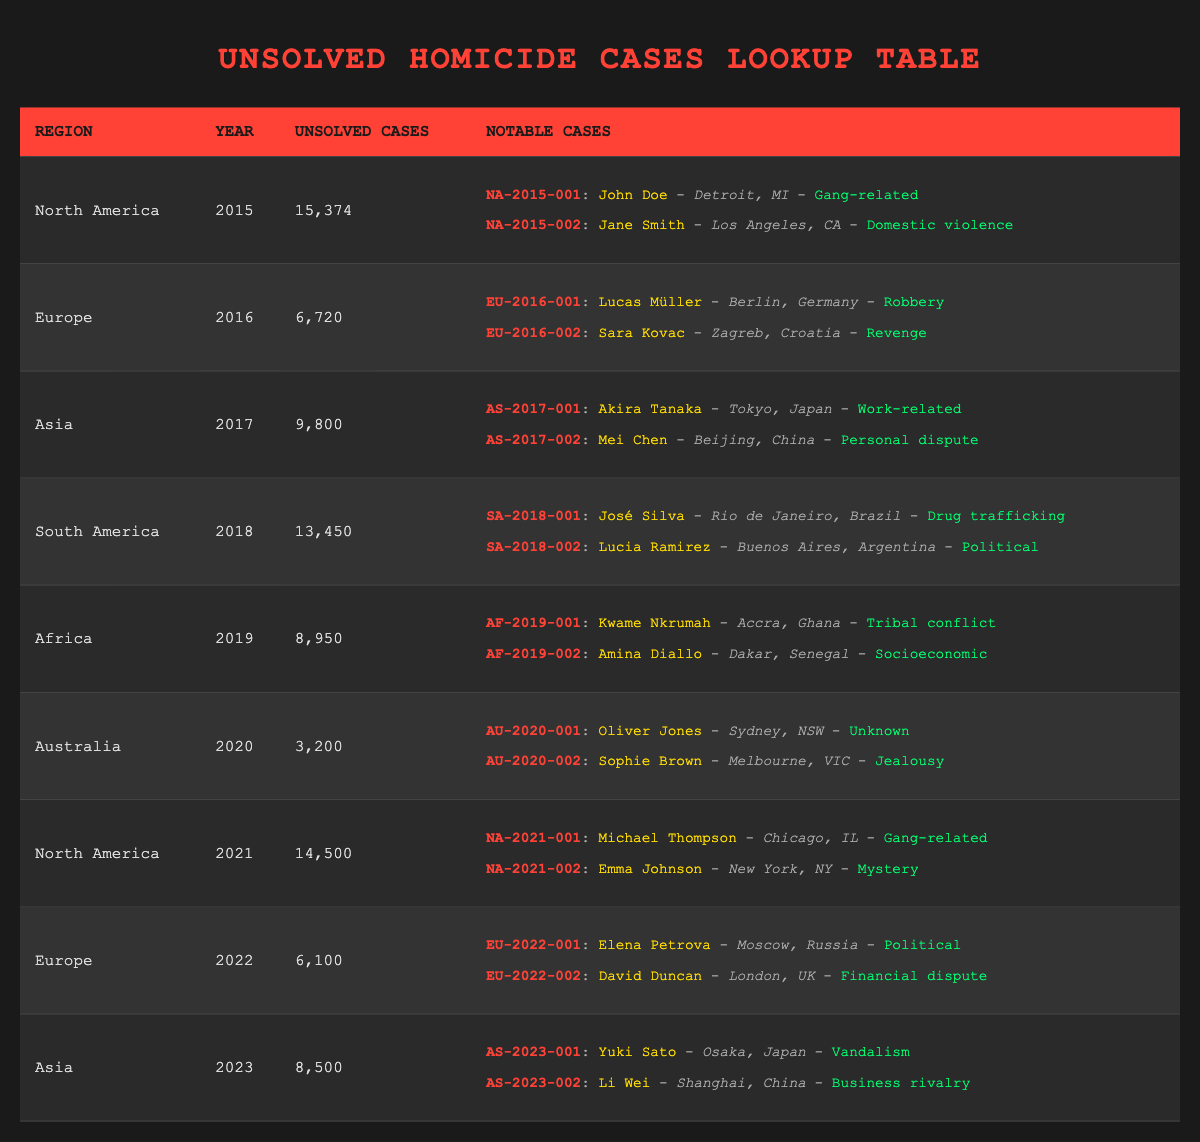What region had the highest number of unsolved homicide cases in 2015? According to the table, North America had 15,374 unsolved homicide cases in 2015, which is higher than any other region listed for that year.
Answer: North America How many unsolved cases were there in South America in 2018? The table shows that South America had 13,450 unsolved homicide cases in 2018.
Answer: 13,450 What is the difference in the number of unsolved cases between Europe in 2016 and Europe in 2022? Europe had 6,720 unsolved cases in 2016 and 6,100 cases in 2022. The difference is 6,720 - 6,100 = 620.
Answer: 620 Did Africa have more unsolved homicide cases in 2019 than Australia in 2020? Yes, Africa had 8,950 unsolved cases in 2019, while Australia had 3,200 cases in 2020.
Answer: Yes What region had the most notable cases listed for the year 2021, and how many were there? The table shows North America had two notable cases listed in 2021. No other region is shown in the same year, so it has the most.
Answer: North America; 2 What was the average number of unsolved homicide cases in Asia from 2017 to 2023? The unsolved cases in Asia over these years were 9,800 (2017), 8,500 (2023). To find the average, add them up (9,800 + 8,500) and divide by 2, 18,300 / 2 = 9,150.
Answer: 9,150 Which year saw the highest number of unsolved homicide cases globally according to the data? The highest number of unsolved cases comes from North America in 2015 with 15,374 cases.
Answer: 2015 How many notable cases were reported in North America from 2015 to 2021? North America had notable cases in 2015 (2), 2021 (2). So, total notable cases = 2 + 2 = 4 notable cases.
Answer: 4 